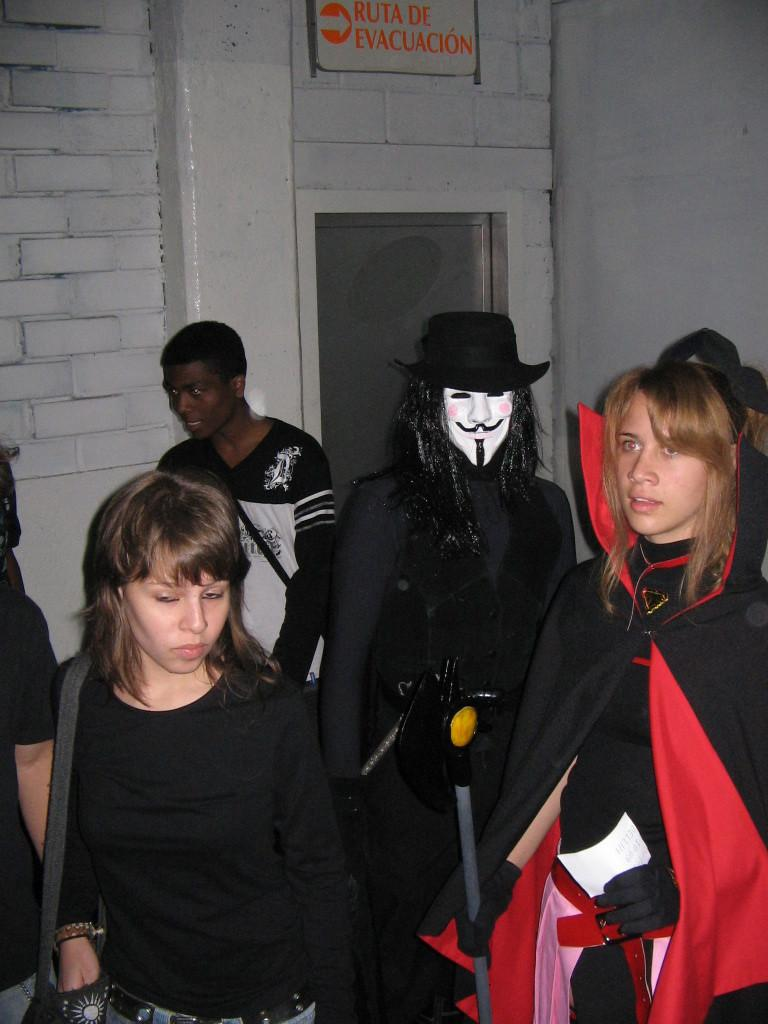How many people are in the image? There are people in the image, but the exact number is not specified. What are some people wearing in the image? Some people are wearing costumes in the image. Can you describe the clothing of one person in the image? One person is wearing a hat in the image. What type of structure can be seen in the image? There is a wall and a door in the image. What is attached to the wall in the image? There is a board with something written on the wall in the image. How many ducks are sitting on the shelf in the image? There is no shelf or duck present in the image. 